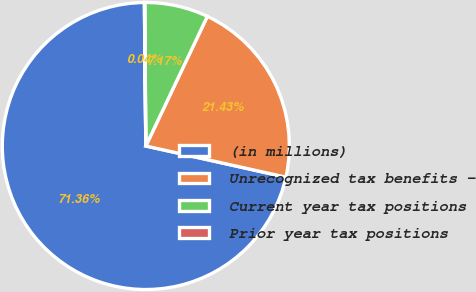<chart> <loc_0><loc_0><loc_500><loc_500><pie_chart><fcel>(in millions)<fcel>Unrecognized tax benefits -<fcel>Current year tax positions<fcel>Prior year tax positions<nl><fcel>71.36%<fcel>21.43%<fcel>7.17%<fcel>0.04%<nl></chart> 